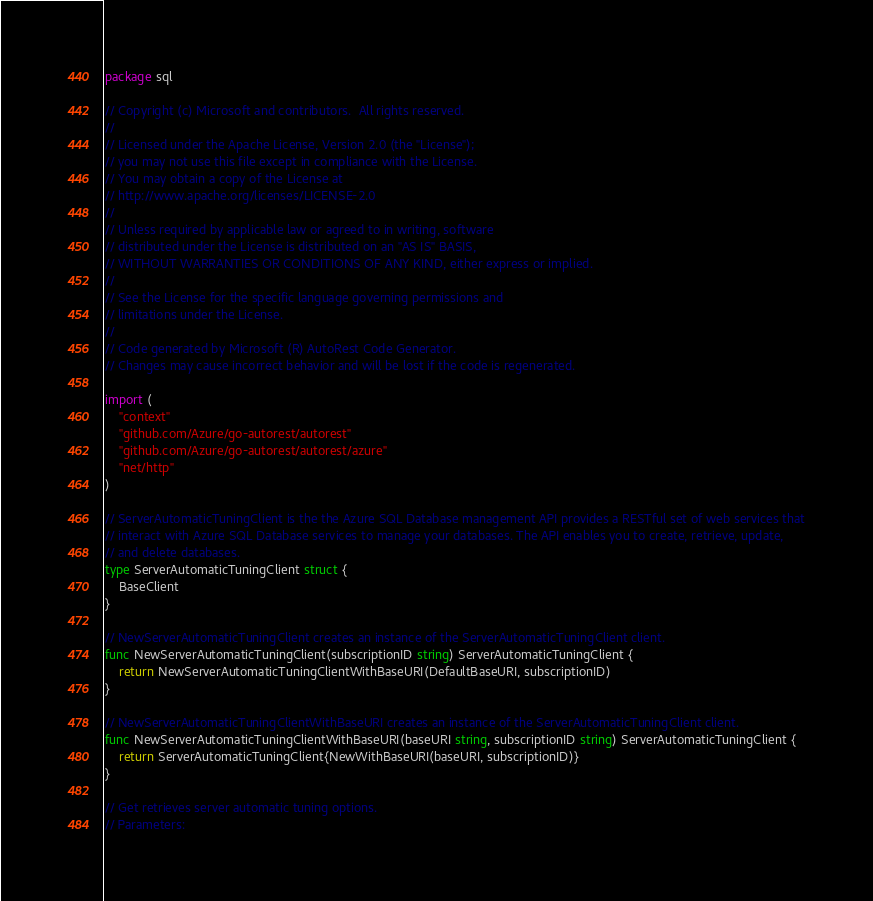Convert code to text. <code><loc_0><loc_0><loc_500><loc_500><_Go_>package sql

// Copyright (c) Microsoft and contributors.  All rights reserved.
//
// Licensed under the Apache License, Version 2.0 (the "License");
// you may not use this file except in compliance with the License.
// You may obtain a copy of the License at
// http://www.apache.org/licenses/LICENSE-2.0
//
// Unless required by applicable law or agreed to in writing, software
// distributed under the License is distributed on an "AS IS" BASIS,
// WITHOUT WARRANTIES OR CONDITIONS OF ANY KIND, either express or implied.
//
// See the License for the specific language governing permissions and
// limitations under the License.
//
// Code generated by Microsoft (R) AutoRest Code Generator.
// Changes may cause incorrect behavior and will be lost if the code is regenerated.

import (
	"context"
	"github.com/Azure/go-autorest/autorest"
	"github.com/Azure/go-autorest/autorest/azure"
	"net/http"
)

// ServerAutomaticTuningClient is the the Azure SQL Database management API provides a RESTful set of web services that
// interact with Azure SQL Database services to manage your databases. The API enables you to create, retrieve, update,
// and delete databases.
type ServerAutomaticTuningClient struct {
	BaseClient
}

// NewServerAutomaticTuningClient creates an instance of the ServerAutomaticTuningClient client.
func NewServerAutomaticTuningClient(subscriptionID string) ServerAutomaticTuningClient {
	return NewServerAutomaticTuningClientWithBaseURI(DefaultBaseURI, subscriptionID)
}

// NewServerAutomaticTuningClientWithBaseURI creates an instance of the ServerAutomaticTuningClient client.
func NewServerAutomaticTuningClientWithBaseURI(baseURI string, subscriptionID string) ServerAutomaticTuningClient {
	return ServerAutomaticTuningClient{NewWithBaseURI(baseURI, subscriptionID)}
}

// Get retrieves server automatic tuning options.
// Parameters:</code> 